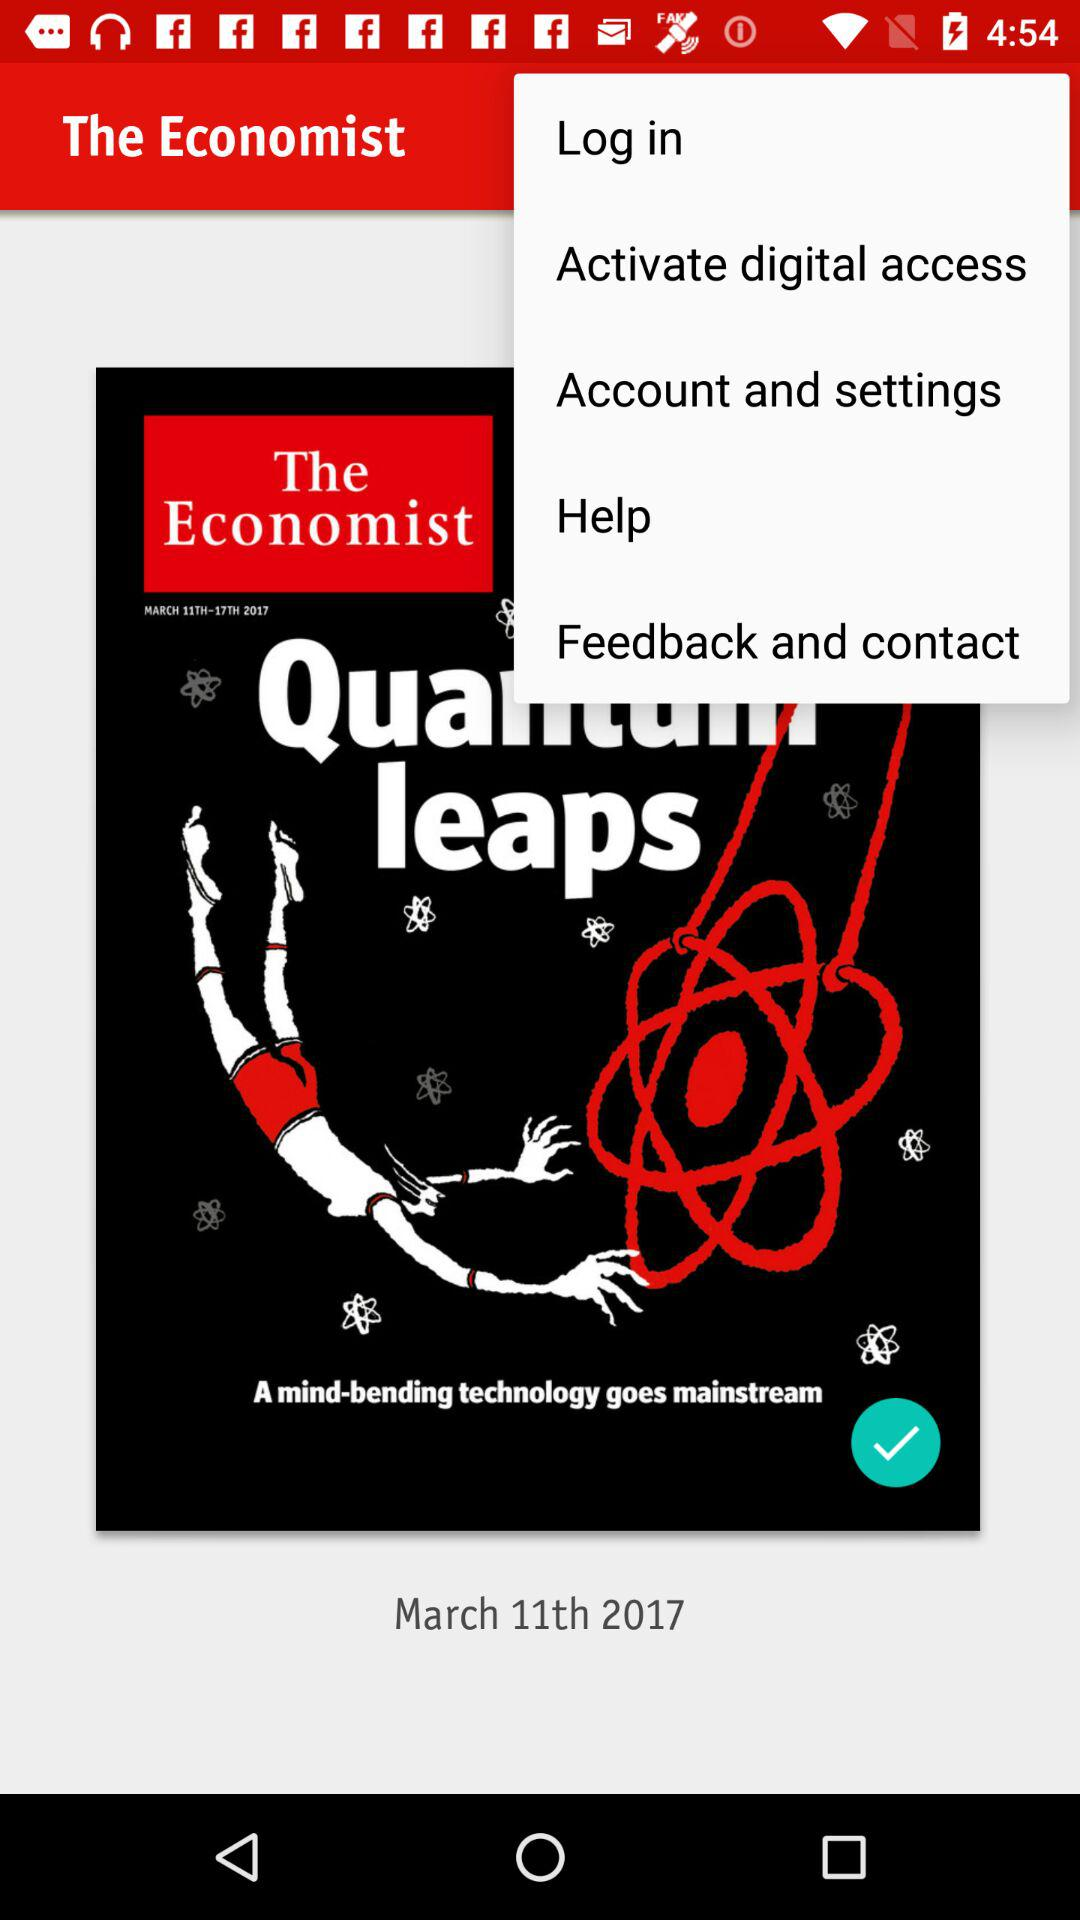What is the title?
When the provided information is insufficient, respond with <no answer>. <no answer> 